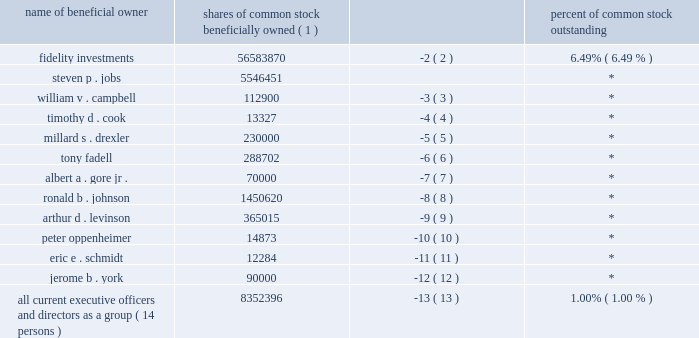Security ownership of 5% ( 5 % ) holders , directors , nominees and executive officers shares of common stock percent of common stock name of beneficial owner beneficially owned ( 1 ) outstanding .
All current executive officers and directors as a group ( 14 persons ) 8352396 ( 13 ) 1.00% ( 1.00 % ) ( 1 ) represents shares of the company 2019s common stock held and options held by such individuals that were exercisable at the table date or within 60 days thereafter .
This does not include options or restricted stock units that vest more than 60 days after the table date .
( 2 ) based on a form 13g/a filed february 14 , 2007 by fmr corp .
Fmr corp .
Lists its address as 82 devonshire street , boston , ma 02109 , in such filing .
( 3 ) includes 110000 shares of the company 2019s common stock that mr .
Campbell has the right to acquire by exercise of stock options .
( 4 ) excludes 600000 unvested restricted stock units .
( 5 ) includes 40000 shares of the company 2019s common stock that mr .
Drexler holds indirectly and 190000 shares of the company 2019s common stock that mr .
Drexler has the right to acquire by exercise of stock options .
( 6 ) includes 275 shares of the company 2019s common stock that mr .
Fadell holds indirectly , 165875 shares of the company 2019s common stock that mr .
Fadell has the right to acquire by exercise of stock options within 60 days after the table date , 1157 shares of the company 2019s common stock held by mr .
Fadell 2019s spouse , and 117375 shares of the company 2019s common stock that mr .
Fadell 2019s spouse has the right to acquire by exercise of stock options within 60 days after the table date .
Excludes 210000 unvested restricted stock units held by mr .
Fadell and 40000 unvested restricted stock units held by mr .
Fadell 2019s spouse .
( 7 ) consists of 70000 shares of the company 2019s common stock that mr .
Gore has the right to acquire by exercise of stock options .
( 8 ) includes 1300000 shares of the company 2019s common stock that mr .
Johnson has the right to acquire by exercise of stock options and excludes 450000 unvested restricted stock units .
( 9 ) includes 2000 shares of the company 2019s common stock held by dr .
Levinson 2019s spouse and 110000 shares of the company 2019s common stock that dr .
Levinson has the right to acquire by exercise of stock options .
( 10 ) excludes 450000 unvested restricted stock units. .
If rsus vest , what would be the total share ownership be for all current executive officers and directors? 
Computations: (((8352396 + 450000) + 450000) + 210000)
Answer: 9462396.0. Security ownership of 5% ( 5 % ) holders , directors , nominees and executive officers shares of common stock percent of common stock name of beneficial owner beneficially owned ( 1 ) outstanding .
All current executive officers and directors as a group ( 14 persons ) 8352396 ( 13 ) 1.00% ( 1.00 % ) ( 1 ) represents shares of the company 2019s common stock held and options held by such individuals that were exercisable at the table date or within 60 days thereafter .
This does not include options or restricted stock units that vest more than 60 days after the table date .
( 2 ) based on a form 13g/a filed february 14 , 2007 by fmr corp .
Fmr corp .
Lists its address as 82 devonshire street , boston , ma 02109 , in such filing .
( 3 ) includes 110000 shares of the company 2019s common stock that mr .
Campbell has the right to acquire by exercise of stock options .
( 4 ) excludes 600000 unvested restricted stock units .
( 5 ) includes 40000 shares of the company 2019s common stock that mr .
Drexler holds indirectly and 190000 shares of the company 2019s common stock that mr .
Drexler has the right to acquire by exercise of stock options .
( 6 ) includes 275 shares of the company 2019s common stock that mr .
Fadell holds indirectly , 165875 shares of the company 2019s common stock that mr .
Fadell has the right to acquire by exercise of stock options within 60 days after the table date , 1157 shares of the company 2019s common stock held by mr .
Fadell 2019s spouse , and 117375 shares of the company 2019s common stock that mr .
Fadell 2019s spouse has the right to acquire by exercise of stock options within 60 days after the table date .
Excludes 210000 unvested restricted stock units held by mr .
Fadell and 40000 unvested restricted stock units held by mr .
Fadell 2019s spouse .
( 7 ) consists of 70000 shares of the company 2019s common stock that mr .
Gore has the right to acquire by exercise of stock options .
( 8 ) includes 1300000 shares of the company 2019s common stock that mr .
Johnson has the right to acquire by exercise of stock options and excludes 450000 unvested restricted stock units .
( 9 ) includes 2000 shares of the company 2019s common stock held by dr .
Levinson 2019s spouse and 110000 shares of the company 2019s common stock that dr .
Levinson has the right to acquire by exercise of stock options .
( 10 ) excludes 450000 unvested restricted stock units. .
If mr . fadell's gave his unvested restricted stock units to a girlfriend , would his wife have more than his girlfriend? 
Computations: (40000 > 210000)
Answer: no. 